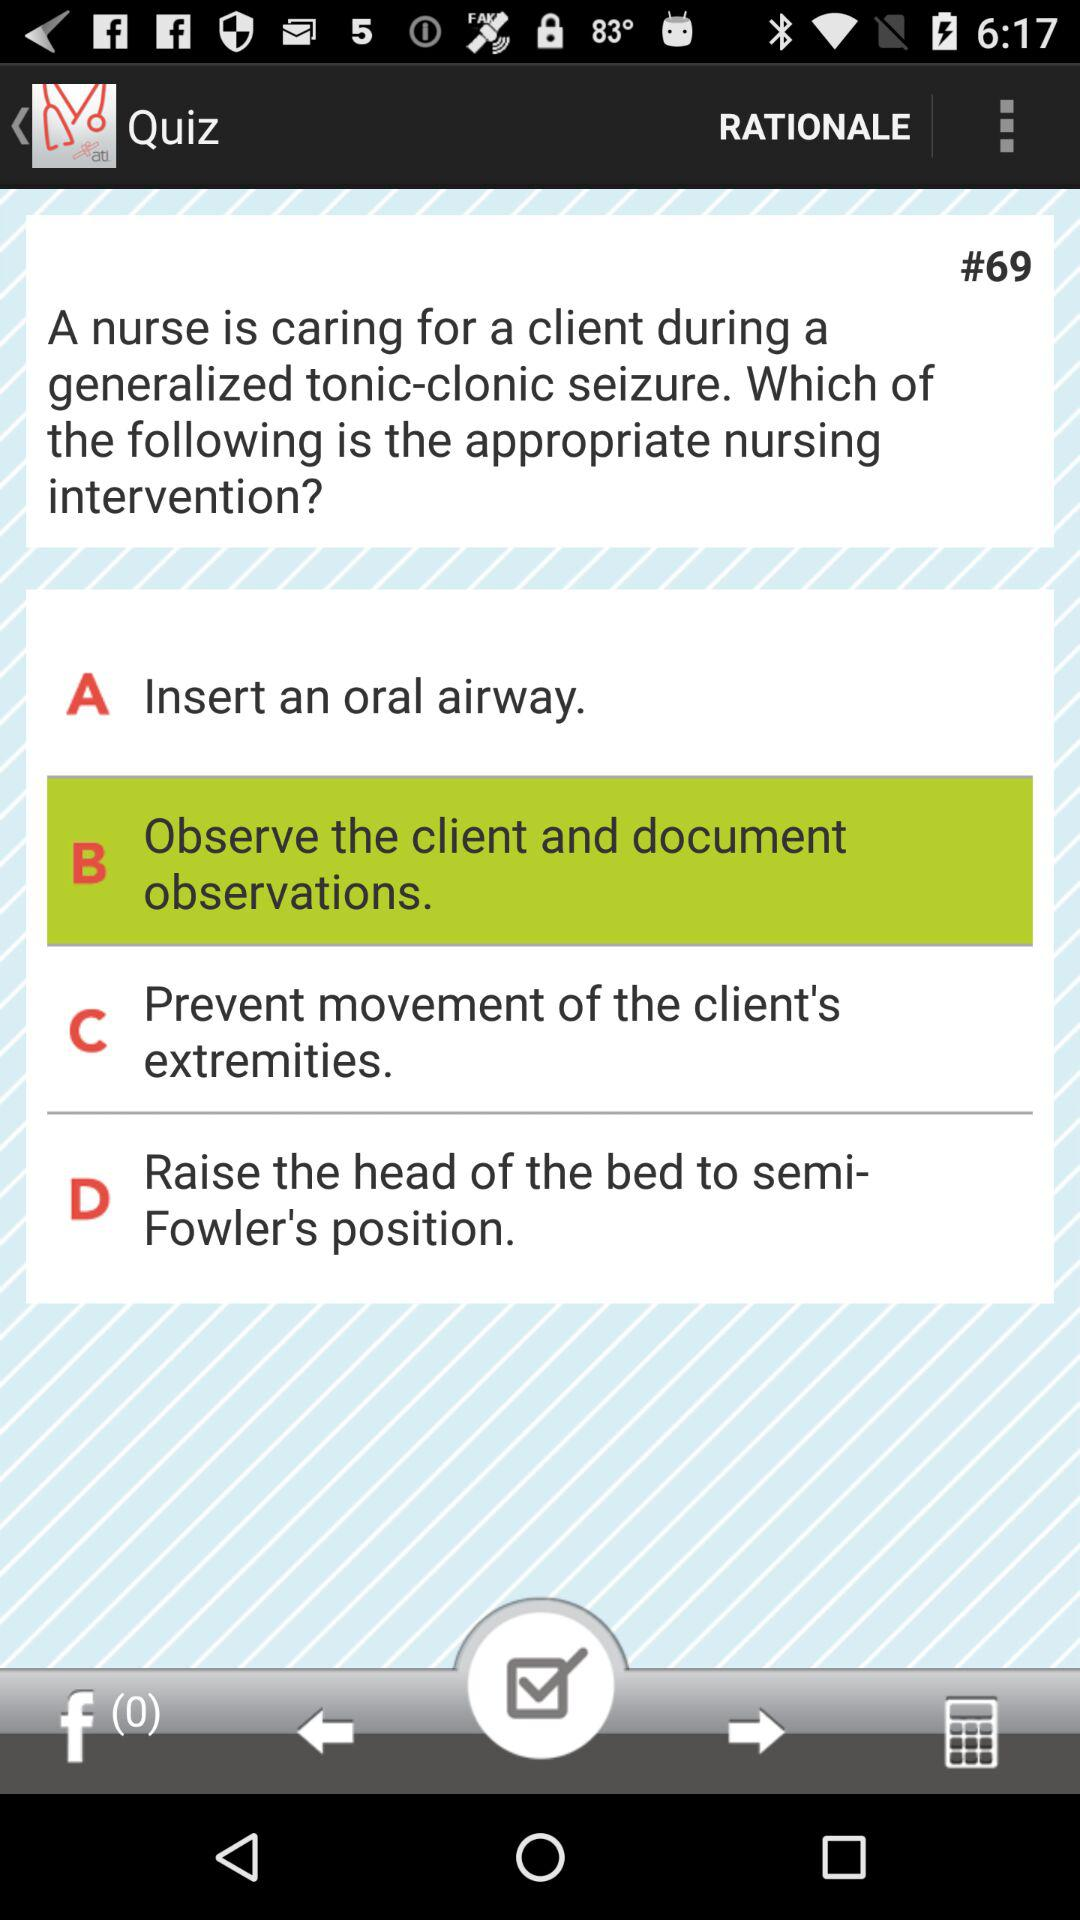What is the selected option? The selected option is "B Observe the client and document observations". 